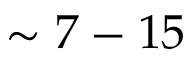<formula> <loc_0><loc_0><loc_500><loc_500>\sim 7 - 1 5</formula> 